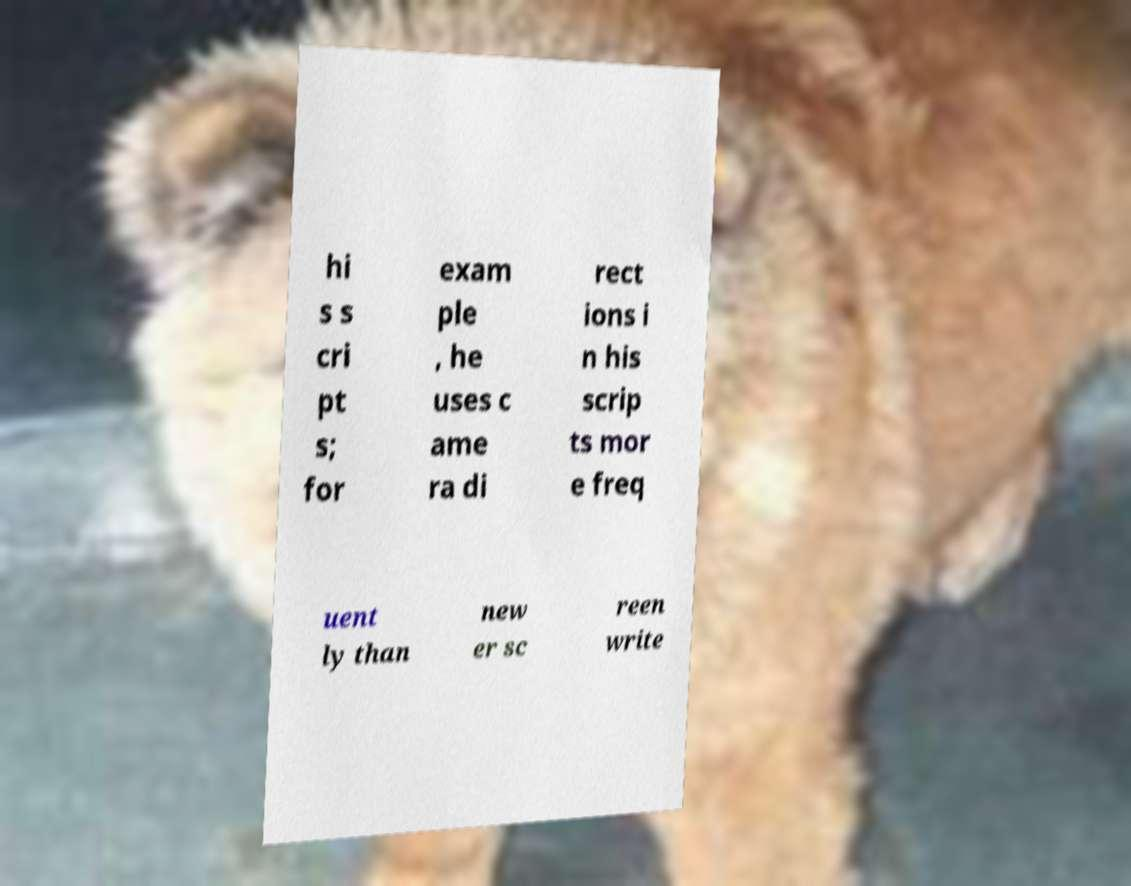Could you assist in decoding the text presented in this image and type it out clearly? hi s s cri pt s; for exam ple , he uses c ame ra di rect ions i n his scrip ts mor e freq uent ly than new er sc reen write 